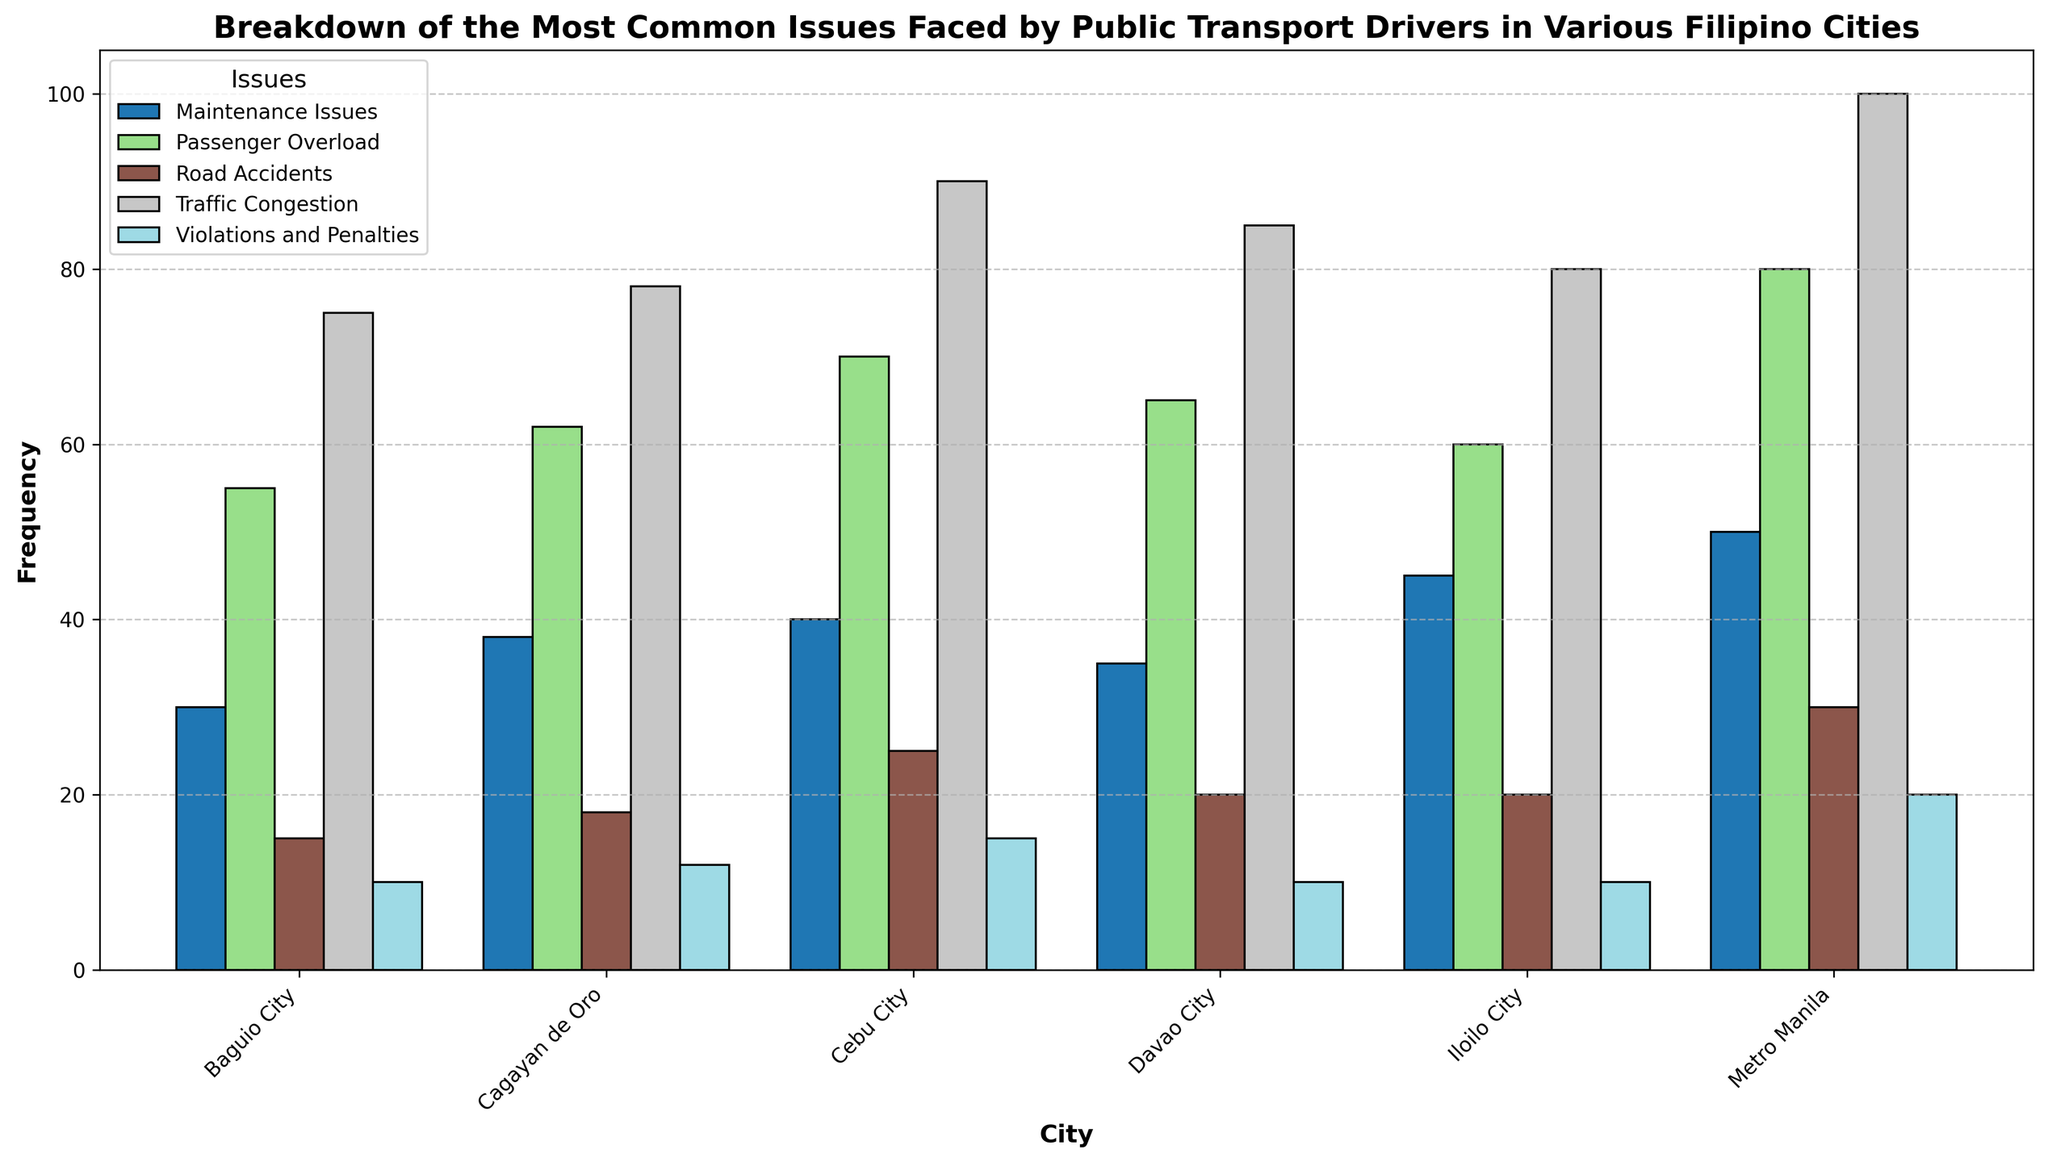What issue in Metro Manila has the highest frequency? Looking at the height of the bars for Metro Manila, the tallest bar represents Traffic Congestion.
Answer: Traffic Congestion In which city is Traffic Congestion the least frequent? By comparing the height of the bars representing Traffic Congestion across all cities, Baguio City's bar is the shortest.
Answer: Baguio City Which city has the most frequent issue with Passenger Overload? In the chart, examine the bars for Passenger Overload. Metro Manila has the tallest bar for this issue.
Answer: Metro Manila Are Maintenance Issues more frequent in Cagayan de Oro or Cebu City? Check the bar heights for Maintenance Issues in both cities. Cebu City's bar is taller than Cagayan de Oro's.
Answer: Cebu City What is the total frequency of Violations and Penalties in all cities combined? Add the frequencies of Violations and Penalties across all cities: 20 (Metro Manila) + 15 (Cebu City) + 10 (Davao City) + 10 (Baguio City) + 10 (Iloilo City) + 12 (Cagayan de Oro) = 77.
Answer: 77 Which city has the fewest issues with Road Accidents? Inspect the bars for Road Accidents across all cities. The shortest bar is in Davao City.
Answer: Davao City How does the frequency of Traffic Congestion in Davao City compare to Iloilo City? Compare the bar heights for Traffic Congestion in both cities. Davao City's bar is taller than Iloilo City's.
Answer: Davao City What is the average frequency of Maintenance Issues across all cities? Sum the frequencies of Maintenance Issues: 50 + 40 + 35 + 30 + 45 + 38 = 238. Divide by the number of cities: 238 / 6 = 39.67.
Answer: 39.67 Is Passenger Overload more frequent in Baguio City or Iloilo City? Compare the heights of the bars for Passenger Overload in both cities. Baguio City's bar is taller than Iloilo City's.
Answer: Baguio City Which issue in Cagayan de Oro has a frequency closest to 20? By checking the bar heights for all issues in Cagayan de Oro, Road Accidents closely match a frequency of 18.
Answer: Road Accidents 